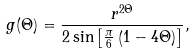<formula> <loc_0><loc_0><loc_500><loc_500>g ( \Theta ) = \frac { r ^ { 2 \Theta } } { 2 \sin \left [ \frac { \pi } { 6 } \left ( 1 - 4 \Theta \right ) \right ] } ,</formula> 